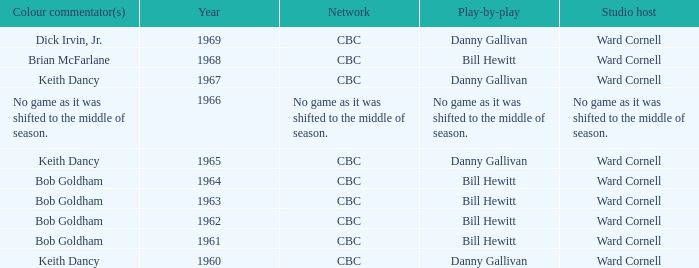Who did the play-by-play on the CBC network before 1961? Danny Gallivan. 